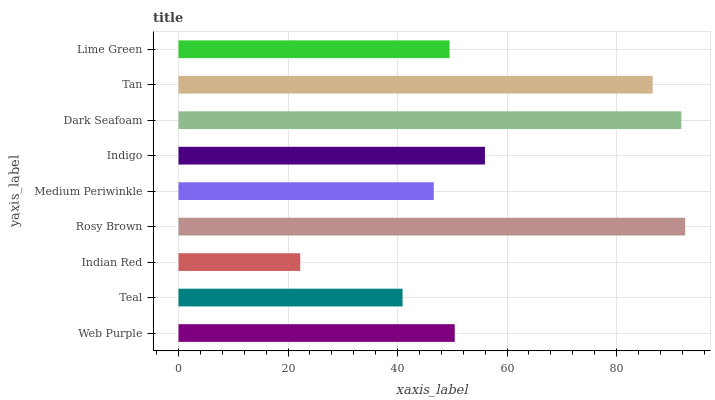Is Indian Red the minimum?
Answer yes or no. Yes. Is Rosy Brown the maximum?
Answer yes or no. Yes. Is Teal the minimum?
Answer yes or no. No. Is Teal the maximum?
Answer yes or no. No. Is Web Purple greater than Teal?
Answer yes or no. Yes. Is Teal less than Web Purple?
Answer yes or no. Yes. Is Teal greater than Web Purple?
Answer yes or no. No. Is Web Purple less than Teal?
Answer yes or no. No. Is Web Purple the high median?
Answer yes or no. Yes. Is Web Purple the low median?
Answer yes or no. Yes. Is Teal the high median?
Answer yes or no. No. Is Dark Seafoam the low median?
Answer yes or no. No. 